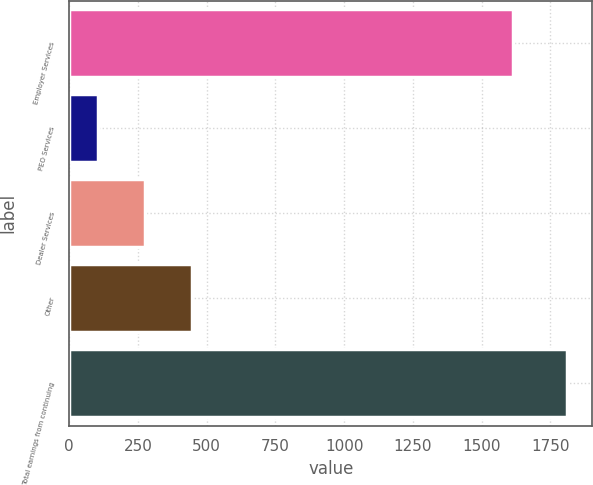Convert chart. <chart><loc_0><loc_0><loc_500><loc_500><bar_chart><fcel>Employer Services<fcel>PEO Services<fcel>Dealer Services<fcel>Other<fcel>Total earnings from continuing<nl><fcel>1615.4<fcel>104.8<fcel>275.52<fcel>446.24<fcel>1812<nl></chart> 